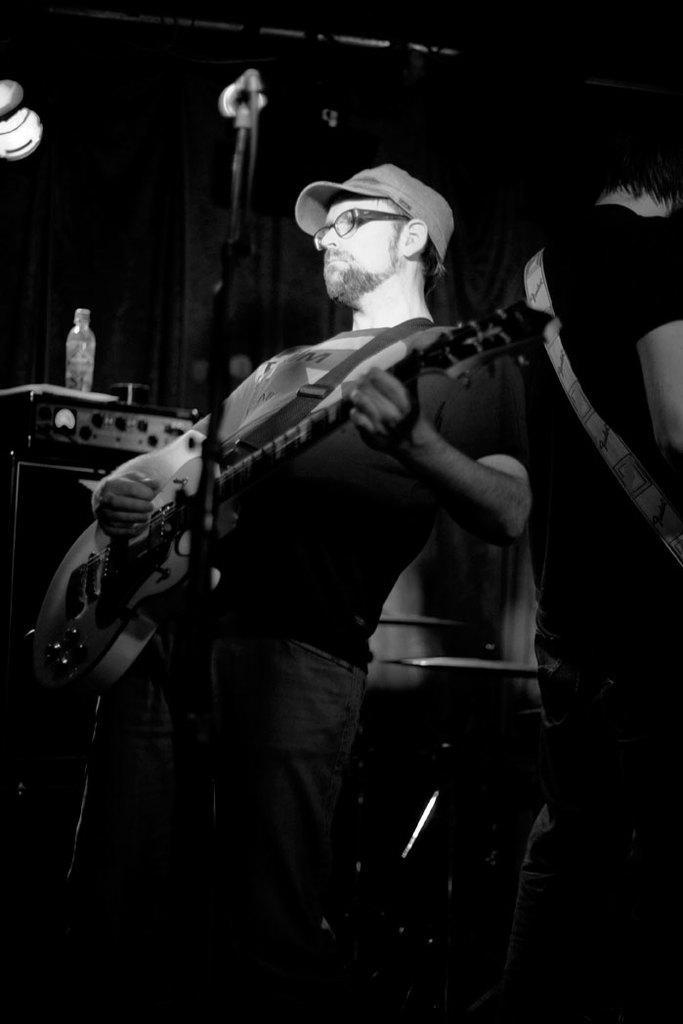Describe this image in one or two sentences. In this image I can see there is a person standing and he is playing guitar, there is a microphone stand in front of him and there is a person standing on the right side and the background of the image is dark. This is a black and white image. 